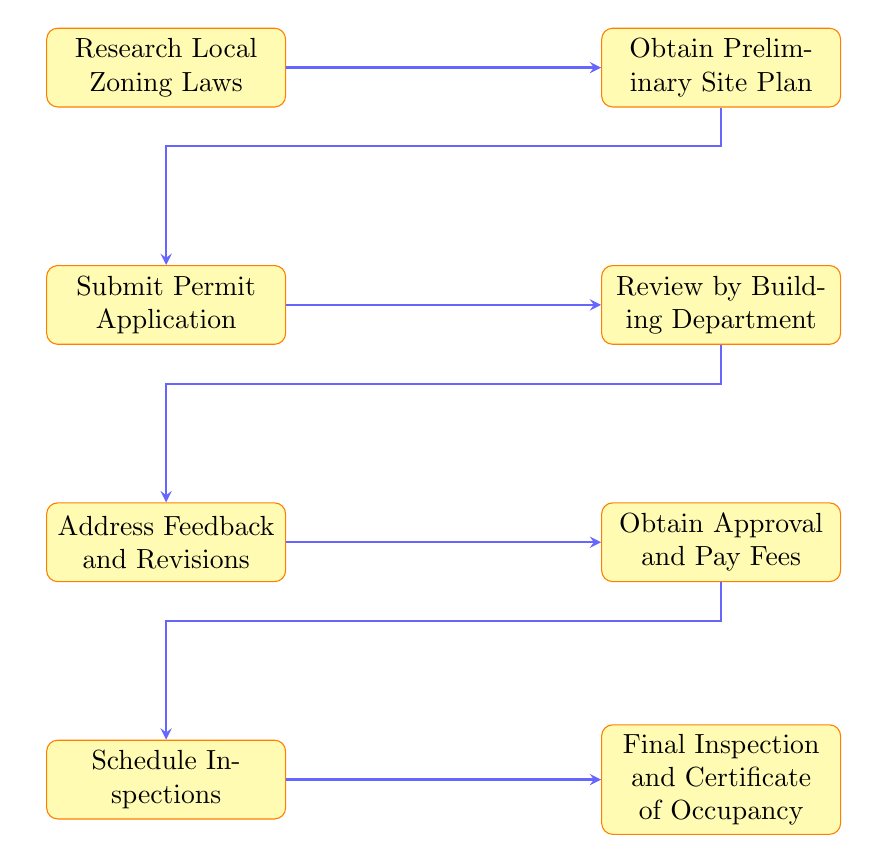What is the first step in the process? The diagram clearly indicates that "Research Local Zoning Laws" is the first node, depicting the initial action needed to obtain building permits.
Answer: Research Local Zoning Laws How many total steps are there in the diagram? By counting each distinct node in the flow chart, there are eight total steps portrayed, each representing a critical phase in the permit acquisition process.
Answer: 8 What follows the step "Obtain Preliminary Site Plan"? The diagram shows that immediately after the "Obtain Preliminary Site Plan" step, the next step is "Submit Permit Application", maintaining a sequential flow between these processes.
Answer: Submit Permit Application Which step involves feedback from the building department? The step named "Address Feedback and Revisions" directly follows the review process by the building department, indicating that it's the stage where feedback is given and revisions may be necessary.
Answer: Address Feedback and Revisions Is there a step after "Final Inspection and Certificate of Occupancy"? The diagram does not list any further steps after "Final Inspection and Certificate of Occupancy", indicating that this is the concluding step in the building permit process.
Answer: No What is the last process in this flow chart? The final node in the flow chart, which denotes the end of the building permit process, is "Final Inspection and Certificate of Occupancy". This represents the completion of the approval journey.
Answer: Final Inspection and Certificate of Occupancy What step must be completed before scheduling inspections? According to the flow chart, the step "Obtain Approval and Pay Fees" must be fully completed before one can move on to "Schedule Inspections", showing the necessary order of operations.
Answer: Obtain Approval and Pay Fees Which two steps are interconnected following submission of the permit application? The diagram demonstrates that "Review by Building Department" directly leads to "Address Feedback and Revisions," illustrating a clear feedback loop in the permit process after the application is submitted.
Answer: Review by Building Department and Address Feedback and Revisions 